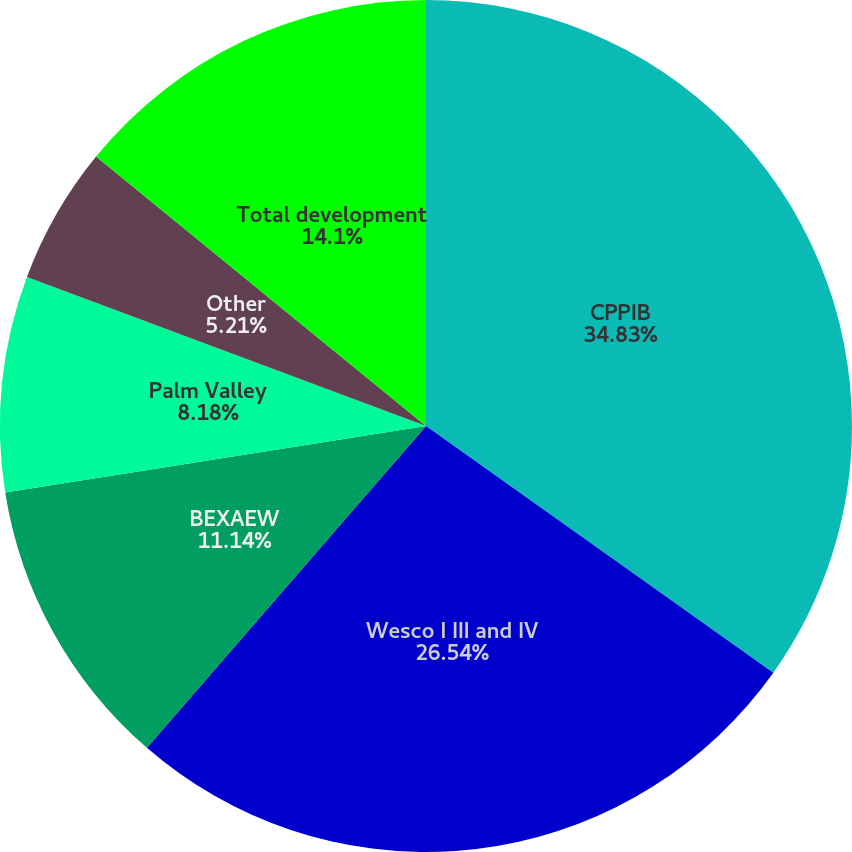<chart> <loc_0><loc_0><loc_500><loc_500><pie_chart><fcel>CPPIB<fcel>Wesco I III and IV<fcel>BEXAEW<fcel>Palm Valley<fcel>Other<fcel>Total development<nl><fcel>34.83%<fcel>26.54%<fcel>11.14%<fcel>8.18%<fcel>5.21%<fcel>14.1%<nl></chart> 